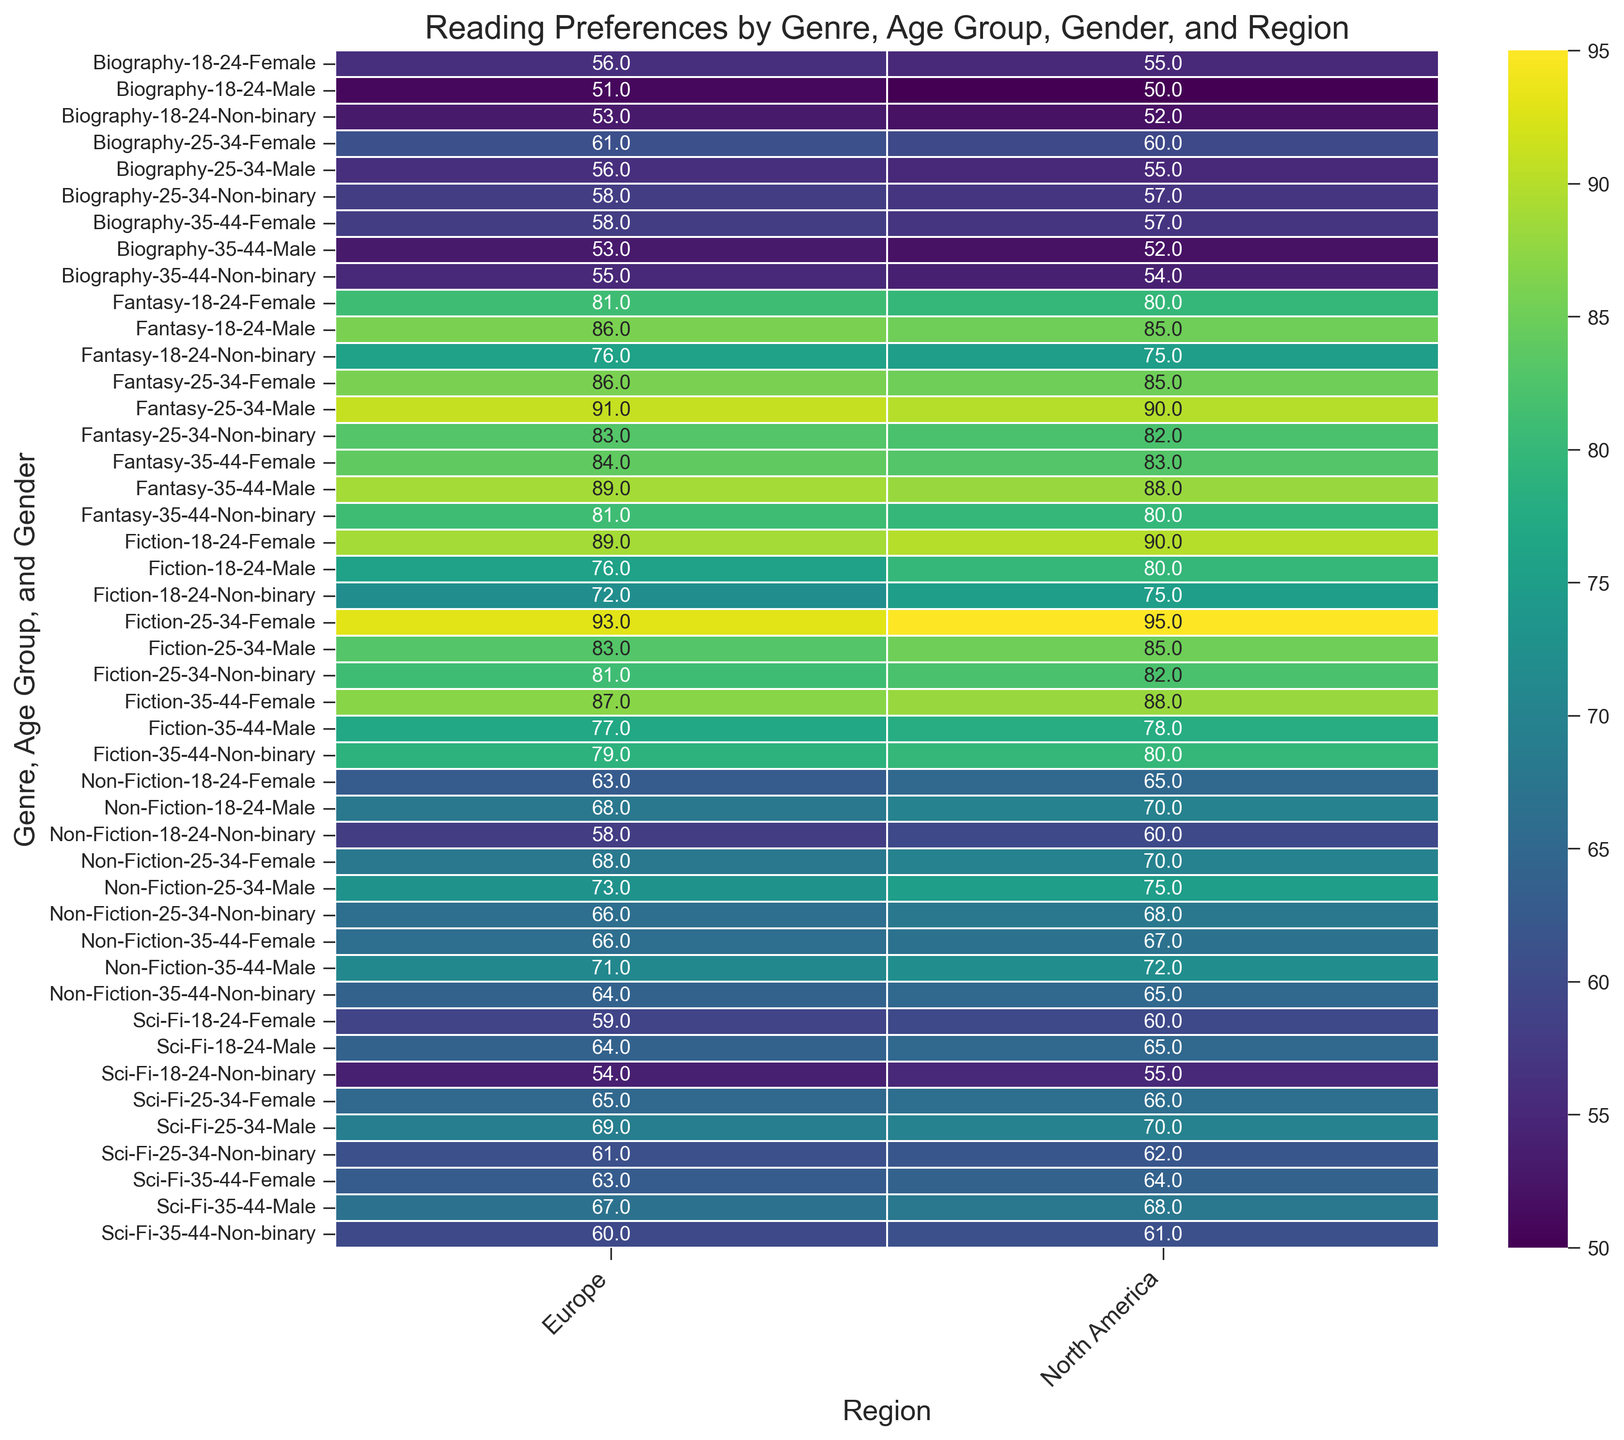Which genre has the highest average preference score in the 25-34 age group across both regions? To find this, we need to compare the average preference scores of each genre in the 25-34 age group across North America and Europe. Sum the preference scores for each genre in both regions and then calculate the average for each genre. Fiction has 85 (M) + 95 (F) + 82 (NB) + 83 (M) + 93 (F) + 81 (NB) = 529, and the average is 529/6 = 88.17. Non-Fiction has 75 (M) + 70 (F) + 68 (NB) + 73 (M)+ 68 (F) + 66 (NB) = 420, and the average is 420/6 = 70. Sci-Fi has 70 (M) + 66 (F) + 62 (NB) + 69 (M) + 65 (F) + 61 (NB) = 393, and the average is 393/6 = 65.5. Fantasy has 90 (M) + 85 (F) + 82 (NB) + 91 (M) + 86 (F) + 83 (NB) = 517, and the average is 517/6 = 86.17, and Biography has 55 (M) + 60 (F) + 57 (NB) + 56 (M) + 61 (F) + 58 (NB) = 347, and the average is 347/6 = 57.83. Fiction has the highest average.
Answer: Fiction Which region shows a higher preference for Fantasy among females aged 18-24? Compare the preference score for Fantasy among females aged 18-24 in North America and Europe. In North America, the score is 80, and in Europe, the score is 81. The higher score indicates the region with a higher preference.
Answer: Europe What is the overall trend in preference score for Non-Fiction across all age groups and genders in North America compared to Europe? To answer this, we compare the Non-Fiction preference scores for corresponding age groups and genders between North America and Europe. Calculate averages for both regions. North America has scores of 70, 65, 60, 75, 70, 68, 72, 67, 65 which average to (70+65+60+75+70+68+72+67+65) / 9 ≈ 67.78. Europe has scores of 68, 63, 58, 73, 68, 66, 71, 66, 64 which average to (68+63+58+73+68+66+71+66+64) / 9 ≈ 66.33. North America shows a slightly higher preference.
Answer: North America Between which genres and regions is the difference in preference score for male readers aged 35-44 the smallest? We need to find the male preference scores aged 35-44 for each genre and region, then calculate differences between regions for each genre. Fiction: 78 (NA) vs 77 (EU), difference = 1. Non-Fiction: 72 (NA) vs 71 (EU), difference = 1. Sci-Fi: 68 (NA) vs 67 (EU), difference = 1. Fantasy: 88 (NA) vs 89 (EU), difference = 1. Biography: 52 (NA) vs 53 (EU), difference = 1. All genres have the smallest difference of 1.
Answer: Fiction, Non-Fiction, Sci-Fi, Fantasy, Biography Is there any genre where North America has a lower preference score than Europe for non-binary readers across all age groups? Compare the non-binary preference scores for all genres and age groups between North America and Europe. Fiction: 75 (NA) vs 72 (EU), 82 (NA) vs 81 (EU), 80 (NA) vs 79 (EU). Non-Fiction: 60 (NA) vs 58 (EU), 68 (NA) vs 66 (EU), 65 (NA) vs 64 (EU). Sci-Fi: 55 (NA) vs 54 (EU), 62 (NA) vs 61 (EU), 61 (NA) vs 60 (EU). Fantasy: 75 (NA) vs 76 (EU), 82 (NA) vs 83 (EU), 80 (NA) vs 81 (EU). Biography: 52 (NA) vs 53 (EU), 57 (NA) vs 58 (EU), 54 (NA) vs 55 (EU). Every genre shows at least one instance where North America has a lower score, indicating that there is no genre that consistently shows lower scores in North America for non-binary readers.
Answer: None What preference score does Fantasy have for non-binary readers aged 18-24 in North America? Locate the value in the heatmap where the genre is Fantasy, age group is 18-24, gender is Non-binary, and region is North America. The score is 75.
Answer: 75 